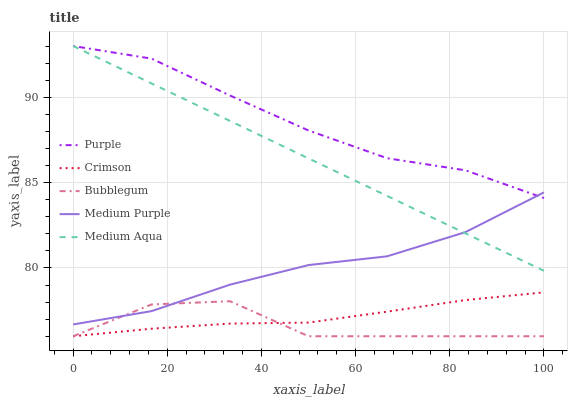Does Bubblegum have the minimum area under the curve?
Answer yes or no. Yes. Does Purple have the maximum area under the curve?
Answer yes or no. Yes. Does Crimson have the minimum area under the curve?
Answer yes or no. No. Does Crimson have the maximum area under the curve?
Answer yes or no. No. Is Medium Aqua the smoothest?
Answer yes or no. Yes. Is Bubblegum the roughest?
Answer yes or no. Yes. Is Crimson the smoothest?
Answer yes or no. No. Is Crimson the roughest?
Answer yes or no. No. Does Crimson have the lowest value?
Answer yes or no. Yes. Does Medium Purple have the lowest value?
Answer yes or no. No. Does Medium Aqua have the highest value?
Answer yes or no. Yes. Does Crimson have the highest value?
Answer yes or no. No. Is Bubblegum less than Purple?
Answer yes or no. Yes. Is Medium Aqua greater than Crimson?
Answer yes or no. Yes. Does Medium Aqua intersect Medium Purple?
Answer yes or no. Yes. Is Medium Aqua less than Medium Purple?
Answer yes or no. No. Is Medium Aqua greater than Medium Purple?
Answer yes or no. No. Does Bubblegum intersect Purple?
Answer yes or no. No. 